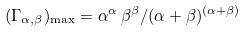Convert formula to latex. <formula><loc_0><loc_0><loc_500><loc_500>( \Gamma _ { \alpha , \beta } ) _ { \max } = \alpha ^ { \alpha } \, \beta ^ { \beta } / ( \alpha + \beta ) ^ { ( \alpha + \beta ) }</formula> 